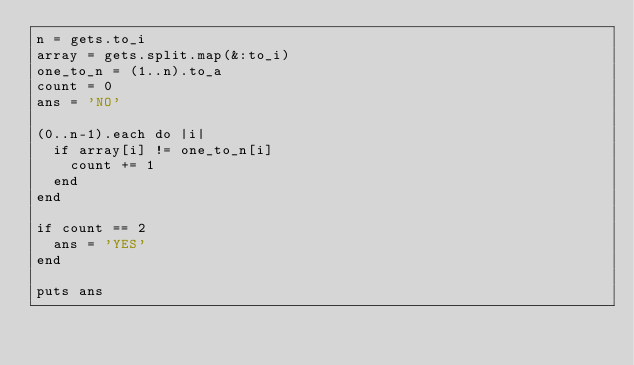Convert code to text. <code><loc_0><loc_0><loc_500><loc_500><_Ruby_>n = gets.to_i
array = gets.split.map(&:to_i)
one_to_n = (1..n).to_a
count = 0
ans = 'NO'

(0..n-1).each do |i|
  if array[i] != one_to_n[i]
    count += 1
  end
end

if count == 2
  ans = 'YES'
end

puts ans</code> 